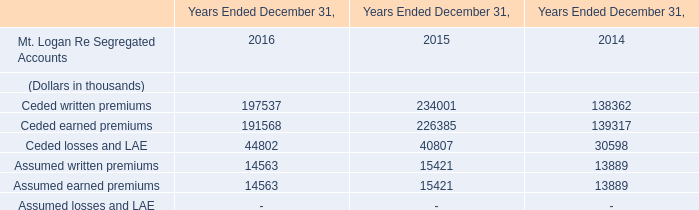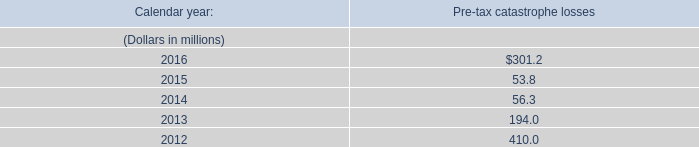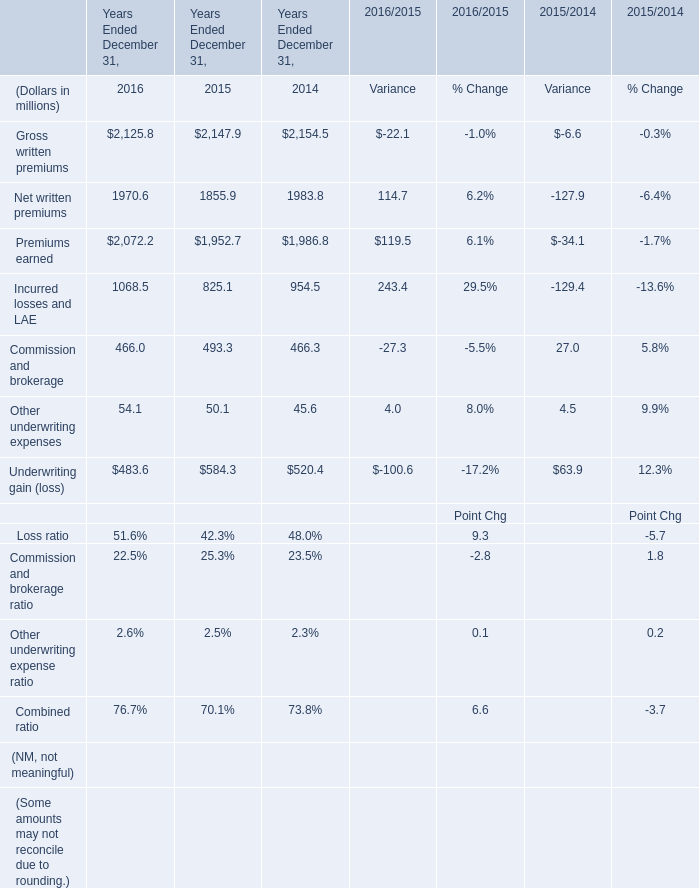What's the current increasing rate of Premiums earned? (in %) 
Computations: ((2072.2 - 1952.7) / 1952.7)
Answer: 0.0612. 